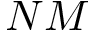Convert formula to latex. <formula><loc_0><loc_0><loc_500><loc_500>N M</formula> 